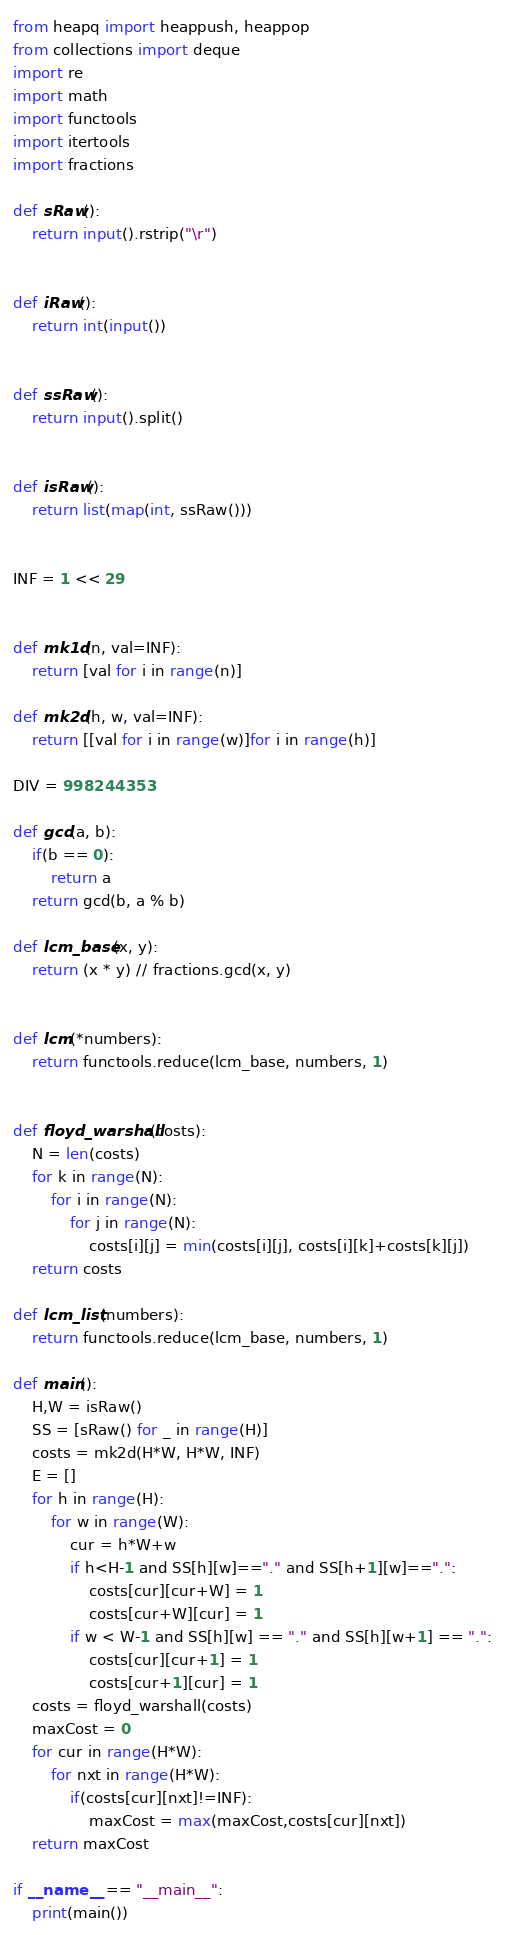<code> <loc_0><loc_0><loc_500><loc_500><_Python_>from heapq import heappush, heappop
from collections import deque
import re
import math
import functools
import itertools
import fractions

def sRaw():
    return input().rstrip("\r")


def iRaw():
    return int(input())


def ssRaw():
    return input().split()


def isRaw():
    return list(map(int, ssRaw()))


INF = 1 << 29


def mk1d(n, val=INF):
    return [val for i in range(n)]

def mk2d(h, w, val=INF):
    return [[val for i in range(w)]for i in range(h)]

DIV = 998244353

def gcd(a, b):
    if(b == 0):
        return a
    return gcd(b, a % b)

def lcm_base(x, y):
    return (x * y) // fractions.gcd(x, y)


def lcm(*numbers):
    return functools.reduce(lcm_base, numbers, 1)


def floyd_warshall(costs):
    N = len(costs)
    for k in range(N):
        for i in range(N):
            for j in range(N):
                costs[i][j] = min(costs[i][j], costs[i][k]+costs[k][j])
    return costs

def lcm_list(numbers):
    return functools.reduce(lcm_base, numbers, 1)

def main():
    H,W = isRaw()
    SS = [sRaw() for _ in range(H)]
    costs = mk2d(H*W, H*W, INF)
    E = []
    for h in range(H):
        for w in range(W):
            cur = h*W+w
            if h<H-1 and SS[h][w]=="." and SS[h+1][w]==".":
                costs[cur][cur+W] = 1
                costs[cur+W][cur] = 1
            if w < W-1 and SS[h][w] == "." and SS[h][w+1] == ".":
                costs[cur][cur+1] = 1
                costs[cur+1][cur] = 1                
    costs = floyd_warshall(costs)
    maxCost = 0
    for cur in range(H*W):
        for nxt in range(H*W):
            if(costs[cur][nxt]!=INF):
                maxCost = max(maxCost,costs[cur][nxt])
    return maxCost

if __name__ == "__main__":
    print(main())
</code> 